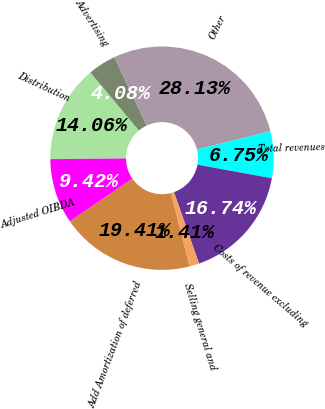Convert chart to OTSL. <chart><loc_0><loc_0><loc_500><loc_500><pie_chart><fcel>Distribution<fcel>Advertising<fcel>Other<fcel>Total revenues<fcel>Costs of revenue excluding<fcel>Selling general and<fcel>Add Amortization of deferred<fcel>Adjusted OIBDA<nl><fcel>14.06%<fcel>4.08%<fcel>28.13%<fcel>6.75%<fcel>16.74%<fcel>1.41%<fcel>19.41%<fcel>9.42%<nl></chart> 